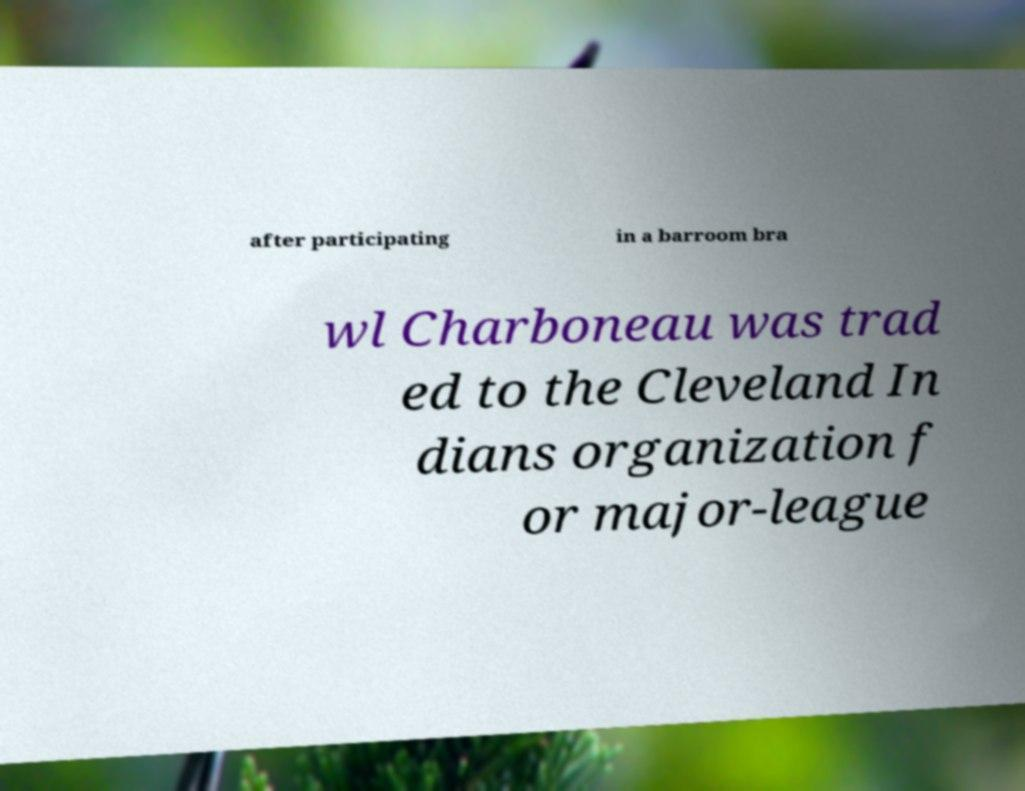For documentation purposes, I need the text within this image transcribed. Could you provide that? after participating in a barroom bra wl Charboneau was trad ed to the Cleveland In dians organization f or major-league 